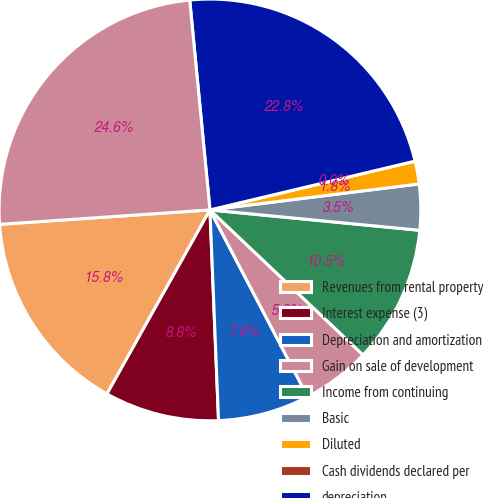Convert chart to OTSL. <chart><loc_0><loc_0><loc_500><loc_500><pie_chart><fcel>Revenues from rental property<fcel>Interest expense (3)<fcel>Depreciation and amortization<fcel>Gain on sale of development<fcel>Income from continuing<fcel>Basic<fcel>Diluted<fcel>Cash dividends declared per<fcel>depreciation<fcel>Total assets<nl><fcel>15.79%<fcel>8.77%<fcel>7.02%<fcel>5.26%<fcel>10.53%<fcel>3.51%<fcel>1.75%<fcel>0.0%<fcel>22.81%<fcel>24.56%<nl></chart> 